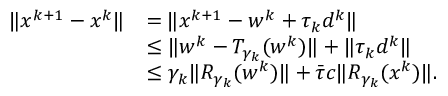Convert formula to latex. <formula><loc_0><loc_0><loc_500><loc_500>\begin{array} { r l } { \| x ^ { k + 1 } - x ^ { k } \| } & { = \| x ^ { k + 1 } - w ^ { k } + \tau _ { k } d ^ { k } \| } \\ & { \leq \| w ^ { k } - T _ { \gamma _ { k } } ( w ^ { k } ) \| + \| \tau _ { k } d ^ { k } \| } \\ & { \leq \gamma _ { k } \| R _ { \gamma _ { k } } ( w ^ { k } ) \| + \bar { \tau } c \| R _ { \gamma _ { k } } ( x ^ { k } ) \| . } \end{array}</formula> 